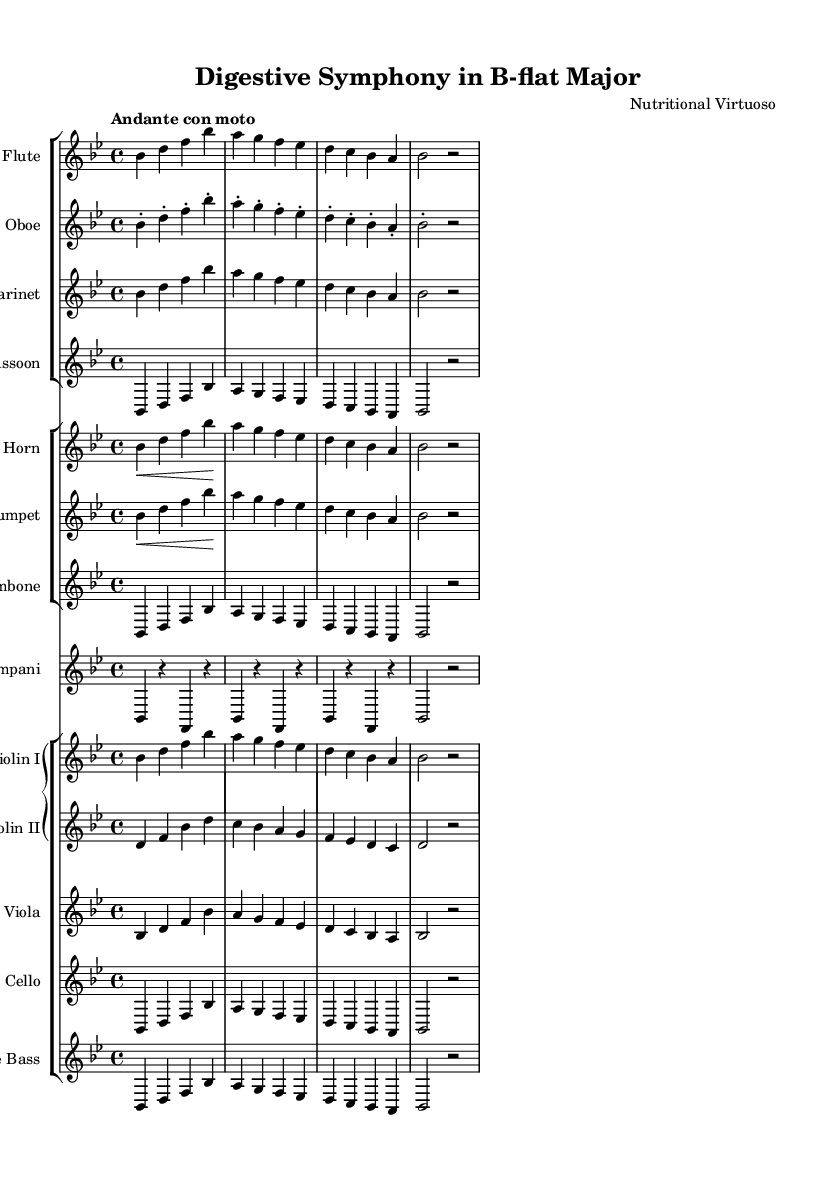What is the key signature of this symphony? The key signature shown at the beginning of the score indicates that the symphony is in B-flat major, as it has two flats (B-flat and E-flat).
Answer: B-flat major What is the time signature of the piece? The time signature displayed at the beginning of the sheet music is 4/4, indicating four beats per measure with a quarter note getting one beat.
Answer: 4/4 What is the tempo marking for this composition? The tempo marking written in the score is "Andante con moto," suggesting a moderately slow speed with a slight movement, typically around 76-108 beats per minute.
Answer: Andante con moto How many different woodwind instruments are featured in this symphony? Referring to the instrumental score, there are four different woodwind instruments: flute, oboe, clarinet, and bassoon.
Answer: Four Which instruments have a line explicitly labeled for Timpani? The score has a dedicated staff for Timpani, indicating that this percussion instrument is included separately and identified in the orchestration.
Answer: Timpani What is the clef used for Violin I in the grand staff? The clef shown for Violin I is the treble clef, which is standard for violin notation, indicating the pitch range for the instrument.
Answer: Treble clef What is the highest note in the melody of flute part based on this score? Reviewing the flute part, the highest note is B-flat, which is indicated as the first note in the respective measure.
Answer: B-flat 